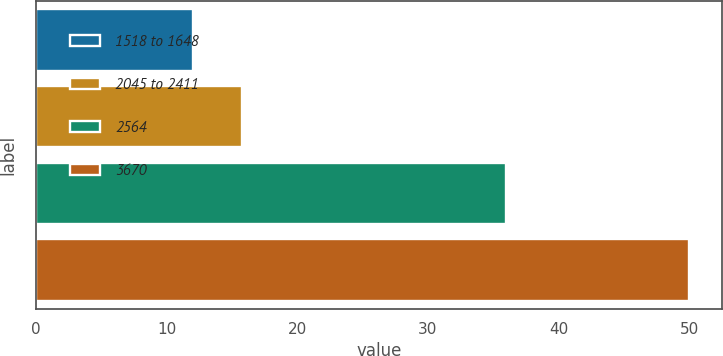Convert chart. <chart><loc_0><loc_0><loc_500><loc_500><bar_chart><fcel>1518 to 1648<fcel>2045 to 2411<fcel>2564<fcel>3670<nl><fcel>12<fcel>15.8<fcel>36<fcel>50<nl></chart> 